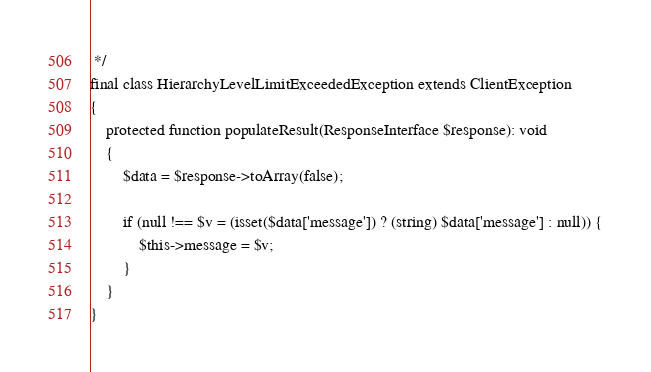Convert code to text. <code><loc_0><loc_0><loc_500><loc_500><_PHP_> */
final class HierarchyLevelLimitExceededException extends ClientException
{
    protected function populateResult(ResponseInterface $response): void
    {
        $data = $response->toArray(false);

        if (null !== $v = (isset($data['message']) ? (string) $data['message'] : null)) {
            $this->message = $v;
        }
    }
}
</code> 